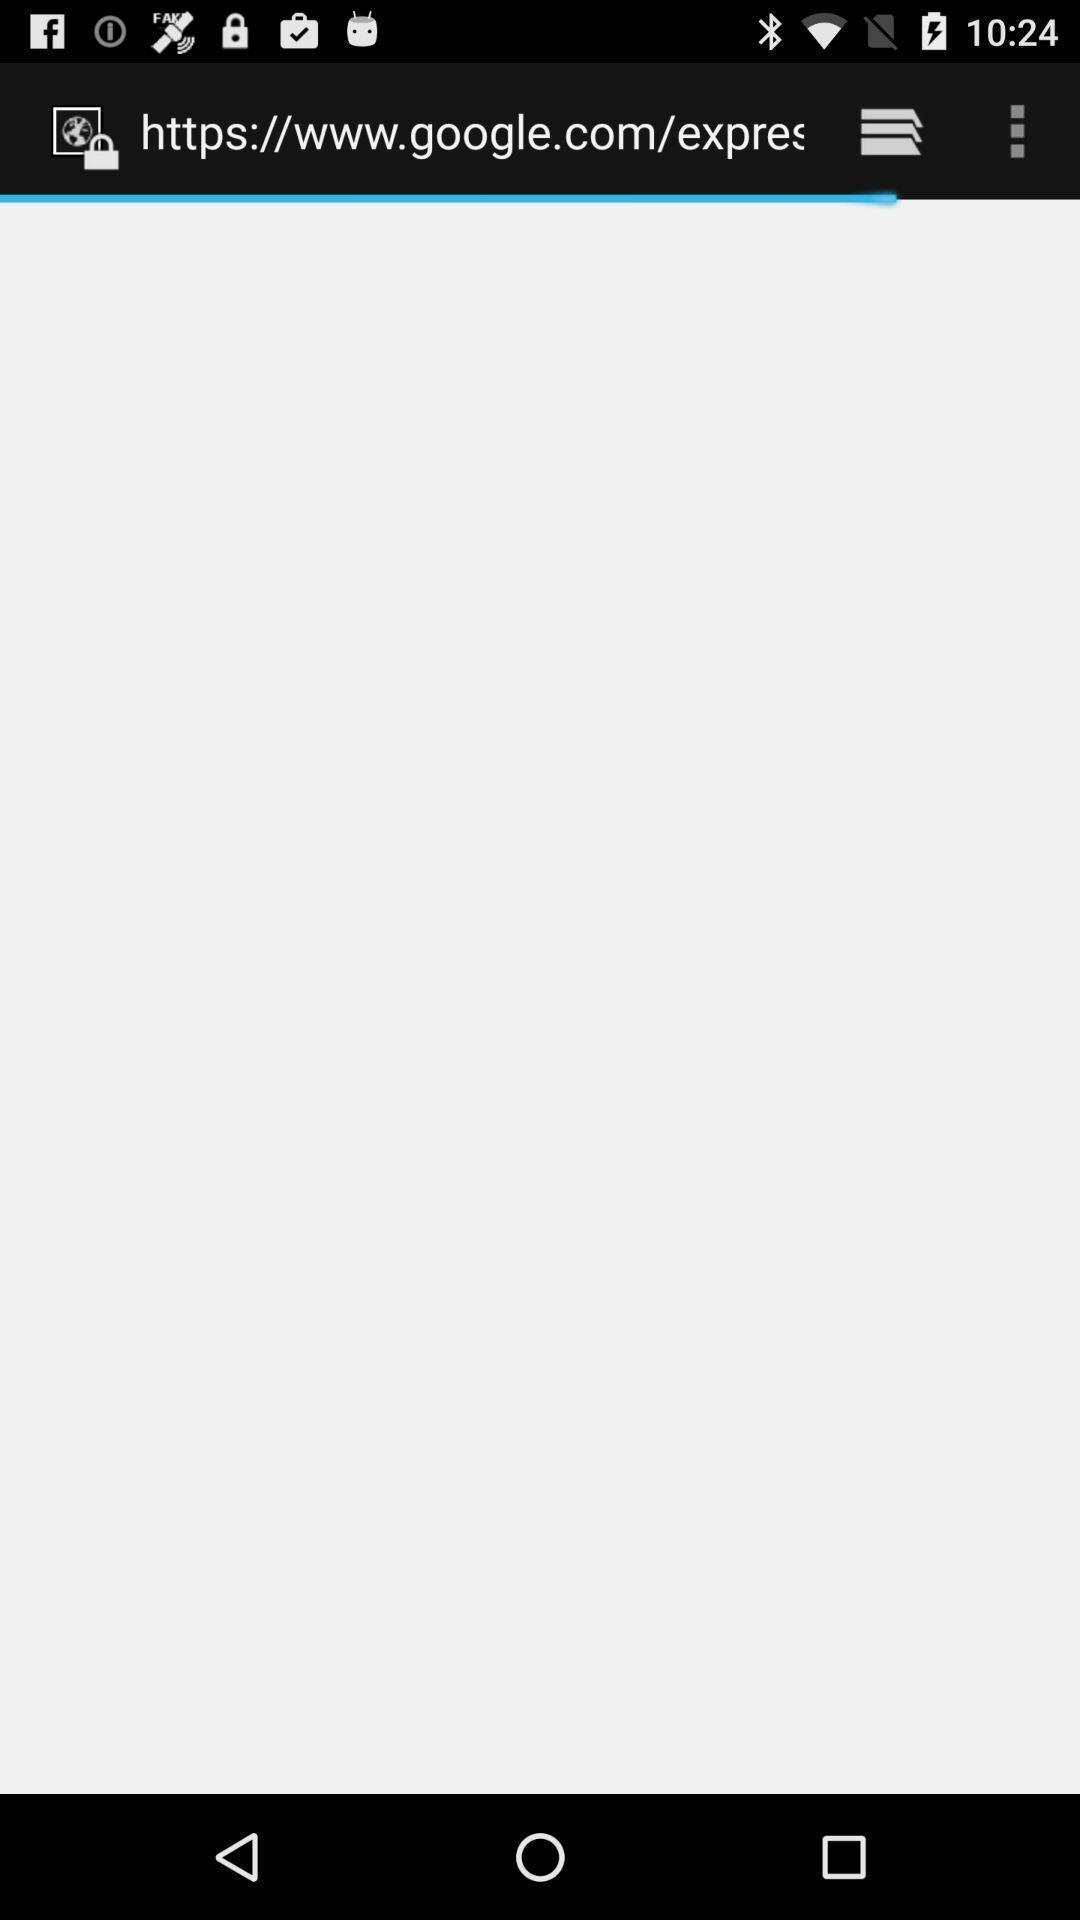Summarize the main components in this picture. Page displaying the setting options. 